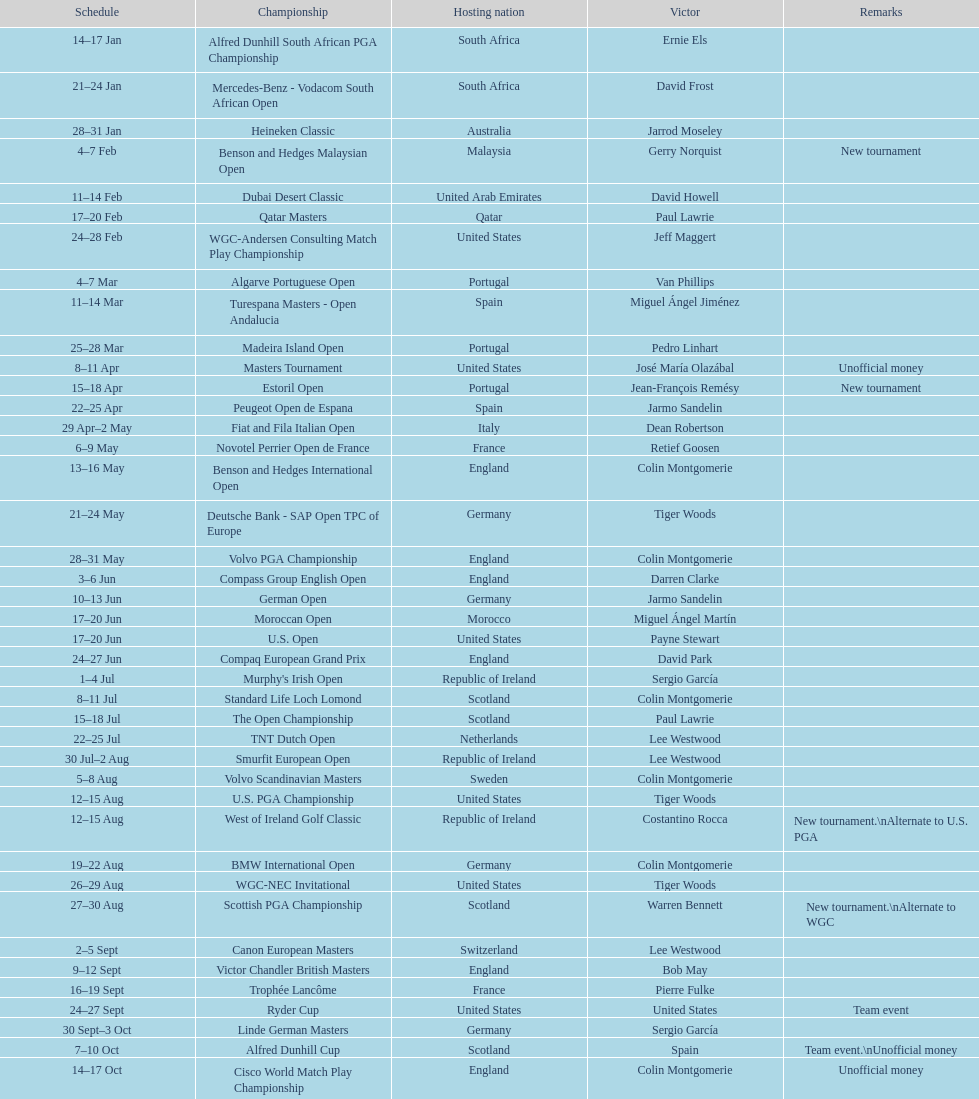Which tournament was later, volvo pga or algarve portuguese open? Volvo PGA. 